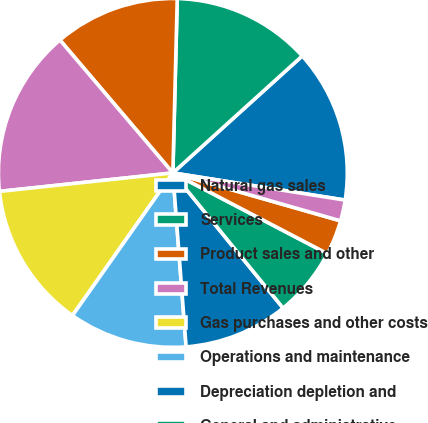Convert chart to OTSL. <chart><loc_0><loc_0><loc_500><loc_500><pie_chart><fcel>Natural gas sales<fcel>Services<fcel>Product sales and other<fcel>Total Revenues<fcel>Gas purchases and other costs<fcel>Operations and maintenance<fcel>Depreciation depletion and<fcel>General and administrative<fcel>Taxes other than income taxes<fcel>Other expense (income)<nl><fcel>14.19%<fcel>12.9%<fcel>11.61%<fcel>15.48%<fcel>13.55%<fcel>10.97%<fcel>9.68%<fcel>6.45%<fcel>3.23%<fcel>1.94%<nl></chart> 